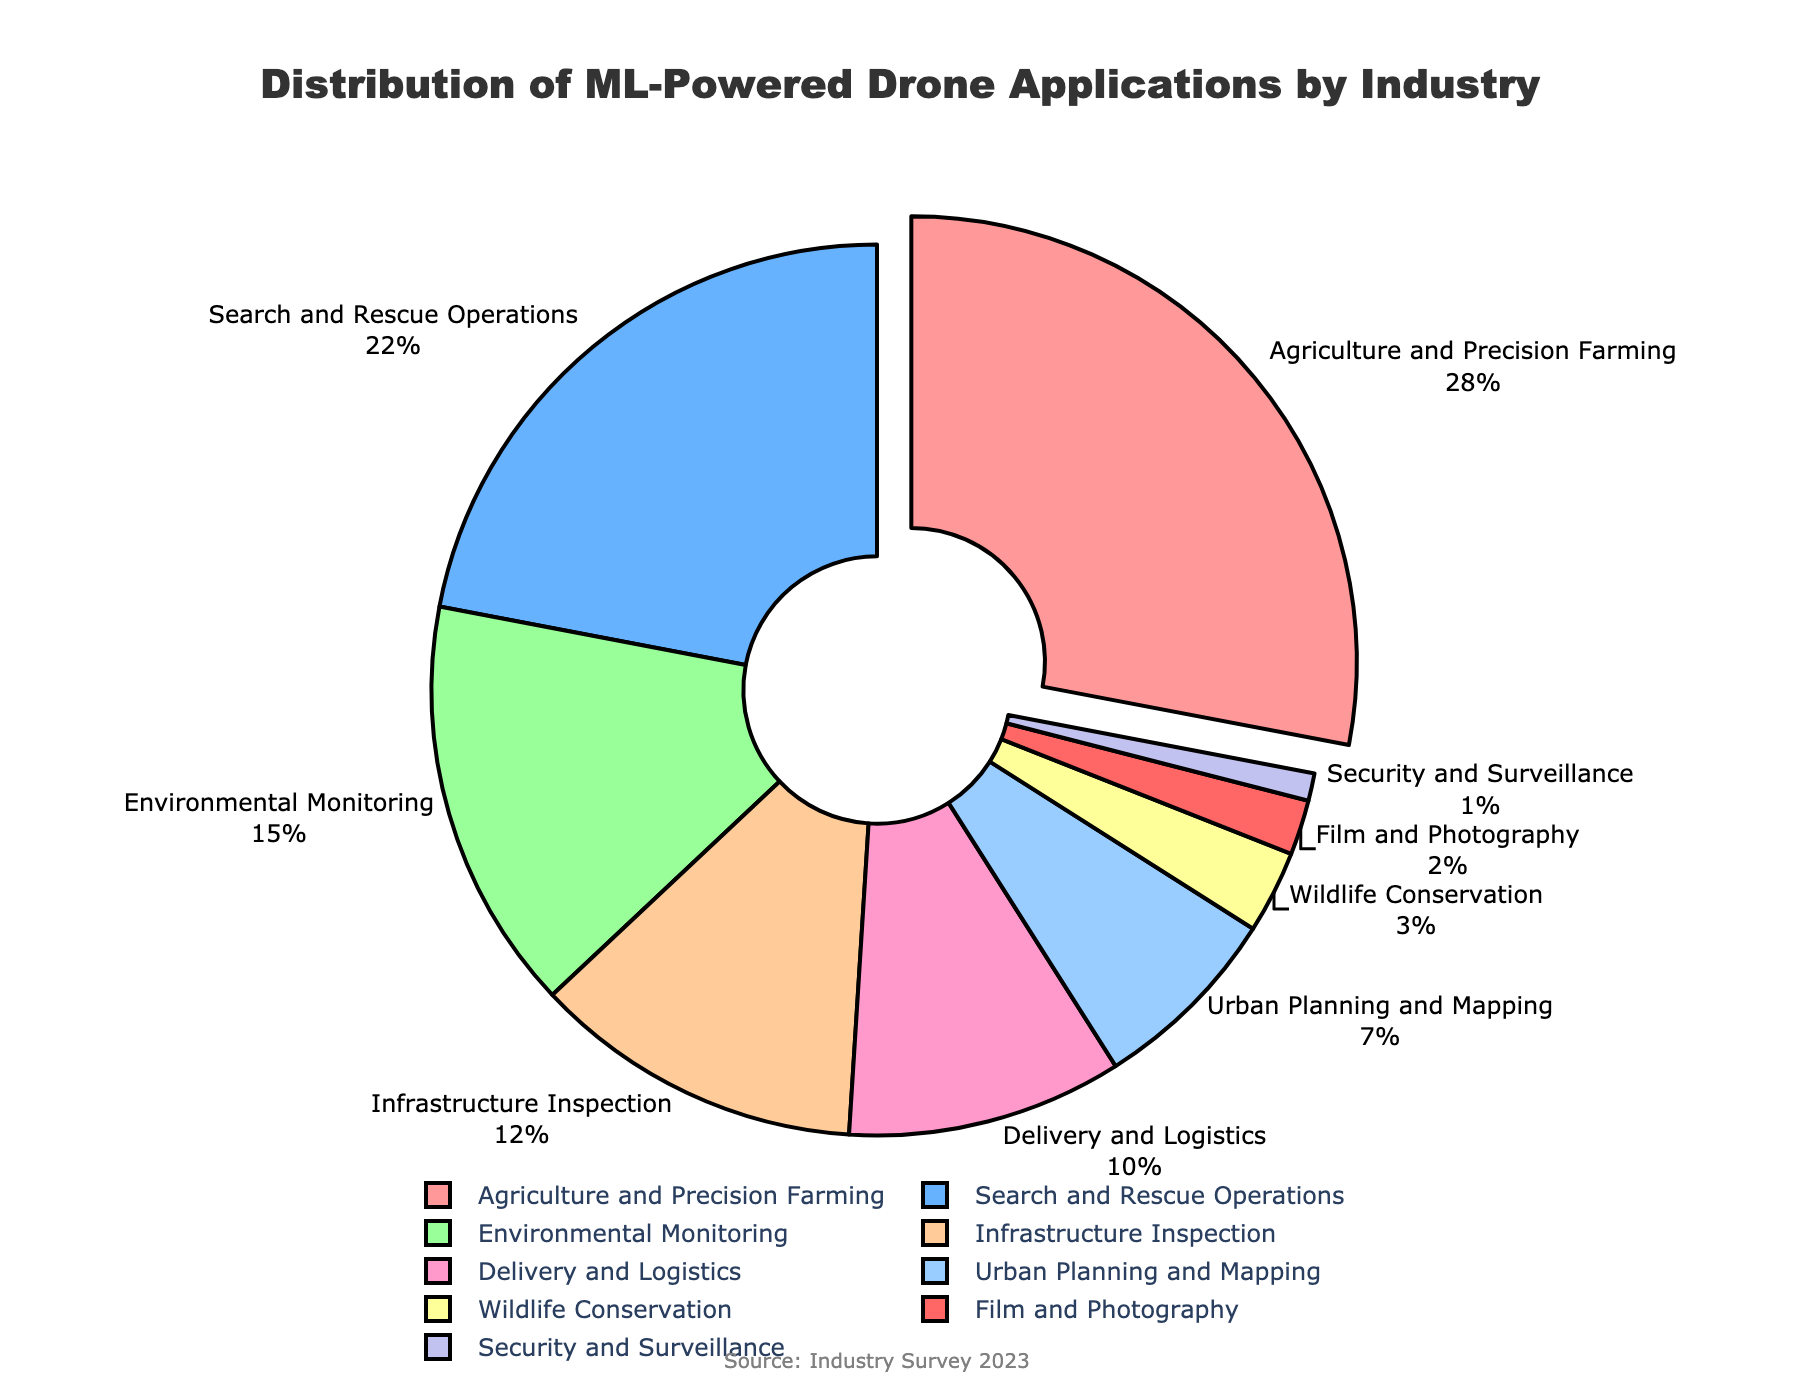Which industry has the highest percentage of drone applications utilizing machine learning for navigation? The industry with the highest percentage is the one with the largest section and highlighted by being pulled out from the pie chart.
Answer: Agriculture and Precision Farming What is the combined percentage of drone applications in Environmental Monitoring, Infrastructure Inspection, and Delivery and Logistics? Sum the percentages of Environmental Monitoring (15%), Infrastructure Inspection (12%), and Delivery and Logistics (10%): 15 + 12 + 10 = 37%
Answer: 37% How does the percentage of drone applications in Search and Rescue Operations compare to those in Urban Planning and Mapping? The percentage for Search and Rescue Operations (22%) is significantly higher than that for Urban Planning and Mapping (7%).
Answer: Search and Rescue Operations is higher Which two industries have the smallest percentage of drone applications? The smallest sections of the pie chart correspond to the industries with the lowest percentages.
Answer: Security and Surveillance, and Film and Photography What is the difference in the percentage of drone applications between Agriculture and Precision Farming and Search and Rescue Operations? Subtract the percentage of Search and Rescue Operations (22%) from that of Agriculture and Precision Farming (28%): 28 - 22 = 6%
Answer: 6% What percentage of drone applications is dedicated to Wildlife Conservation compared to Environmental Monitoring? Observe the percentages on the pie chart: Wildlife Conservation (3%) and Environmental Monitoring (15%). The percentages show that Wildlife Conservation is much smaller.
Answer: Wildlife Conservation is lower How many industries have a percentage of drone applications of 10% or higher? Count the number of sectors with percentages 10% or more: Agriculture and Precision Farming (28%), Search and Rescue Operations (22%), Environmental Monitoring (15%), Infrastructure Inspection (12%), Delivery and Logistics (10%).
Answer: 5 industries What is the color used for the Environmental Monitoring sector in the pie chart? Identify the visual attribute, the color, of the "Environmental Monitoring" slice on the pie chart.
Answer: Green If we combine the percentages of the bottom three industries, what is the total? Add the percentages of the three smallest sectors: Film and Photography (2%), Security and Surveillance (1%), and Wildlife Conservation (3%): 2 + 1 + 3 = 6%
Answer: 6% What is the average percentage for the industries listed in the pie chart? Add up all the percentages and divide by the number of industries: (28 + 22 + 15 + 12 + 10 + 7 + 3 + 2 + 1) / 9 = 100 / 9 ≈ 11.11%
Answer: 11.11% 